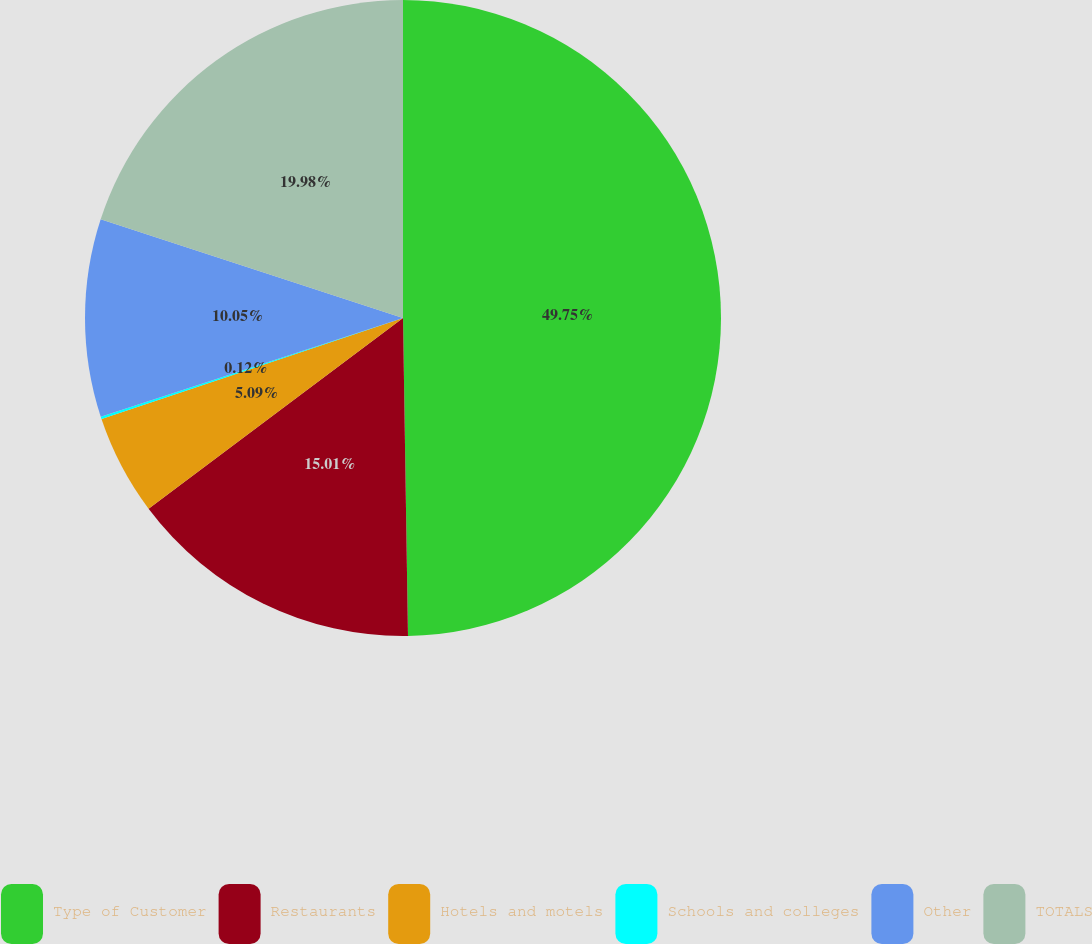Convert chart to OTSL. <chart><loc_0><loc_0><loc_500><loc_500><pie_chart><fcel>Type of Customer<fcel>Restaurants<fcel>Hotels and motels<fcel>Schools and colleges<fcel>Other<fcel>TOTALS<nl><fcel>49.75%<fcel>15.01%<fcel>5.09%<fcel>0.12%<fcel>10.05%<fcel>19.98%<nl></chart> 